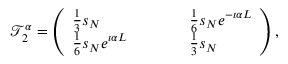<formula> <loc_0><loc_0><loc_500><loc_500>\mathcal { T } _ { 2 } ^ { \alpha } = \left ( \begin{array} { l l l l l } { \frac { 1 } { 3 } s _ { N } } & { \frac { 1 } { 6 } s _ { N } e ^ { - \i \alpha L } } \\ { \frac { 1 } { 6 } s _ { N } e ^ { \i \alpha L } } & { \frac { 1 } { 3 } s _ { N } } \end{array} \right ) ,</formula> 